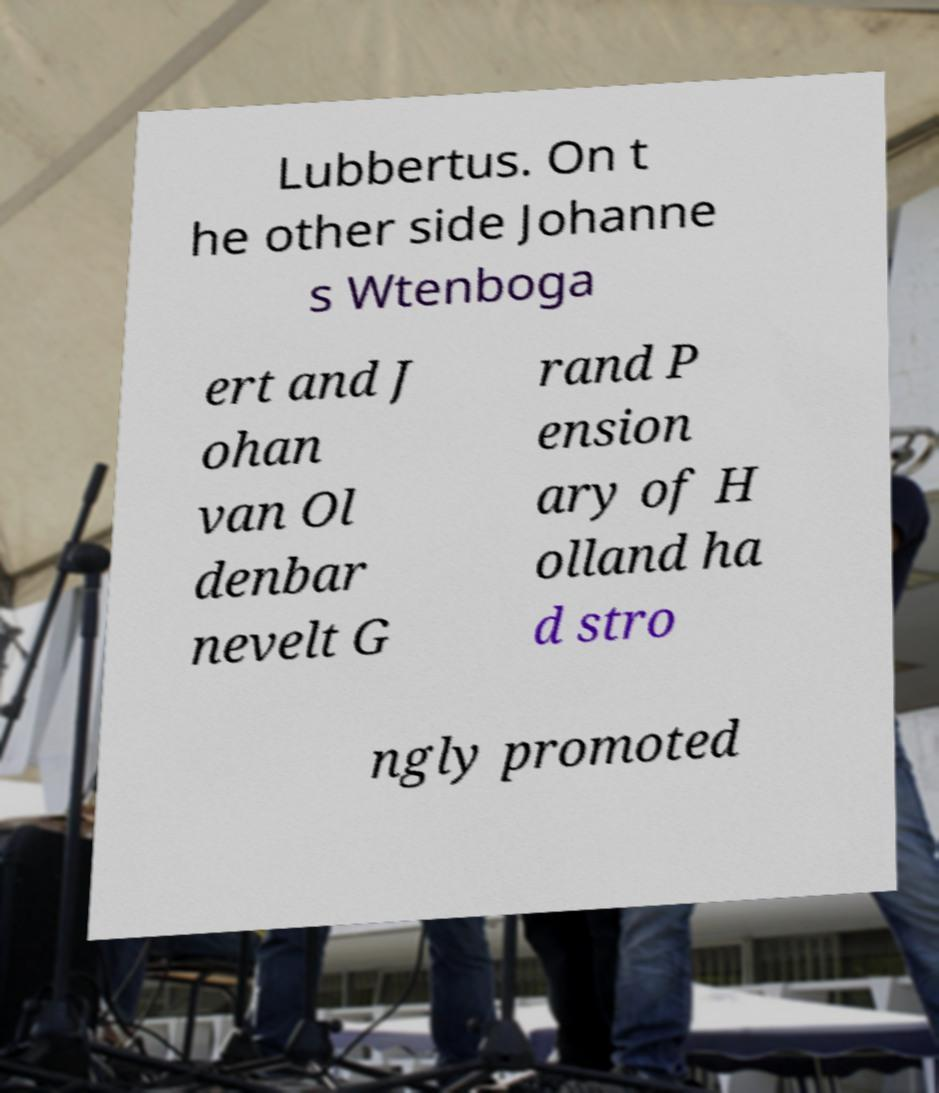What messages or text are displayed in this image? I need them in a readable, typed format. Lubbertus. On t he other side Johanne s Wtenboga ert and J ohan van Ol denbar nevelt G rand P ension ary of H olland ha d stro ngly promoted 